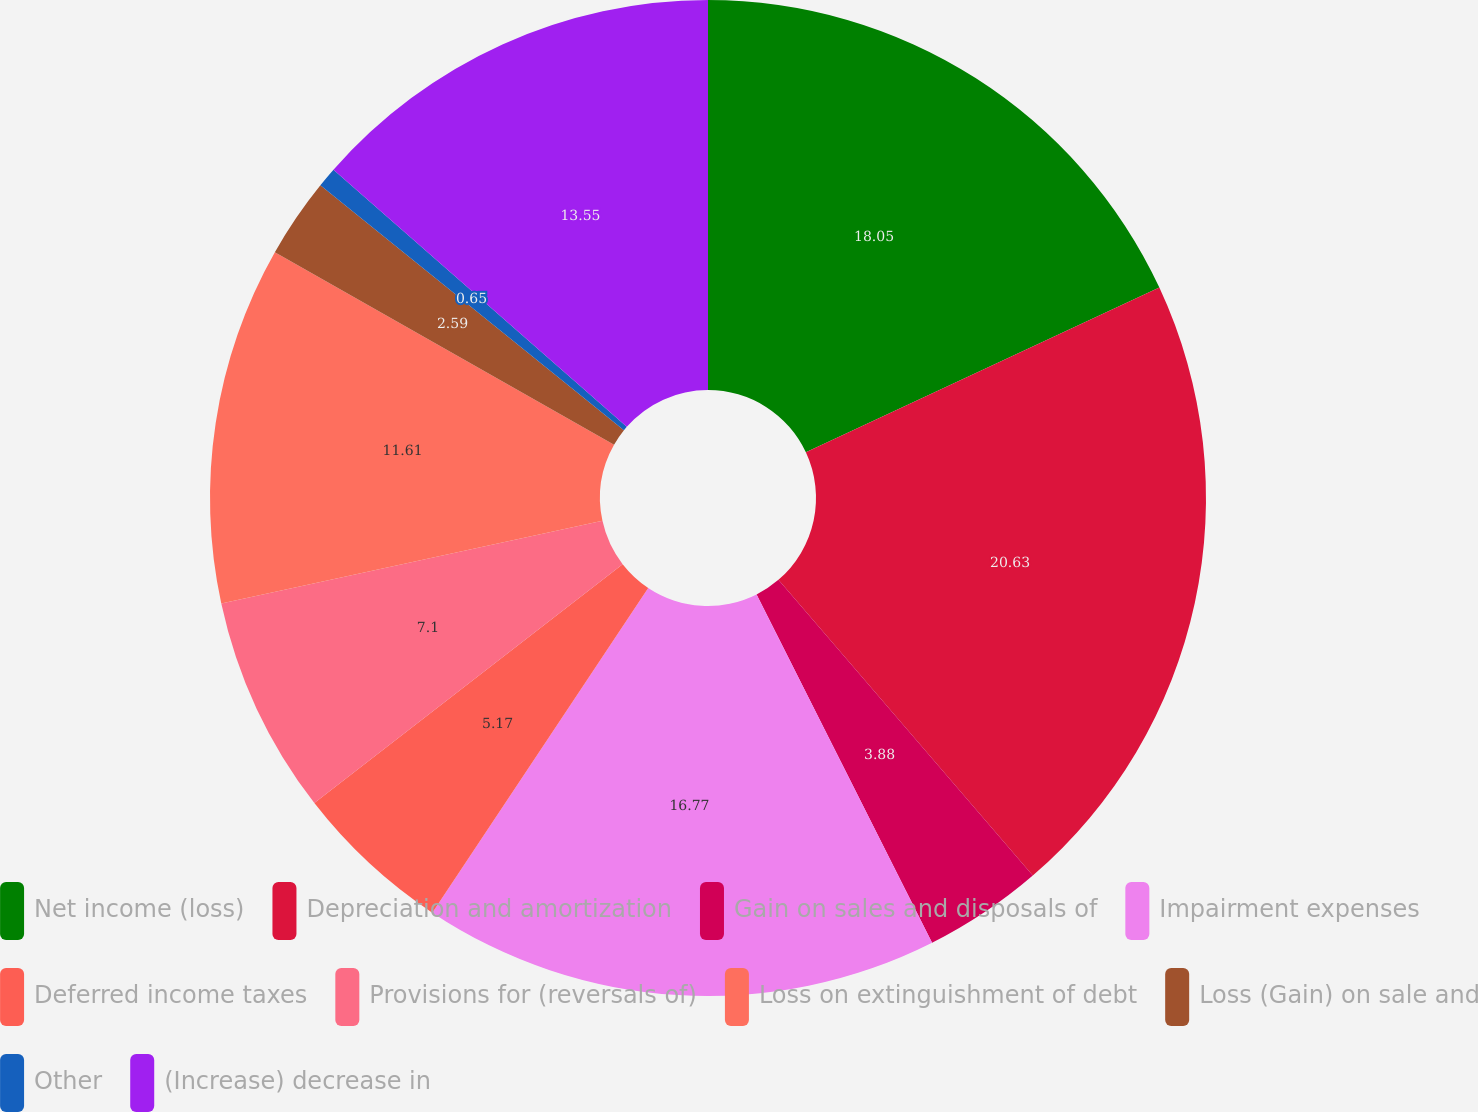Convert chart. <chart><loc_0><loc_0><loc_500><loc_500><pie_chart><fcel>Net income (loss)<fcel>Depreciation and amortization<fcel>Gain on sales and disposals of<fcel>Impairment expenses<fcel>Deferred income taxes<fcel>Provisions for (reversals of)<fcel>Loss on extinguishment of debt<fcel>Loss (Gain) on sale and<fcel>Other<fcel>(Increase) decrease in<nl><fcel>18.06%<fcel>20.64%<fcel>3.88%<fcel>16.77%<fcel>5.17%<fcel>7.1%<fcel>11.61%<fcel>2.59%<fcel>0.65%<fcel>13.55%<nl></chart> 